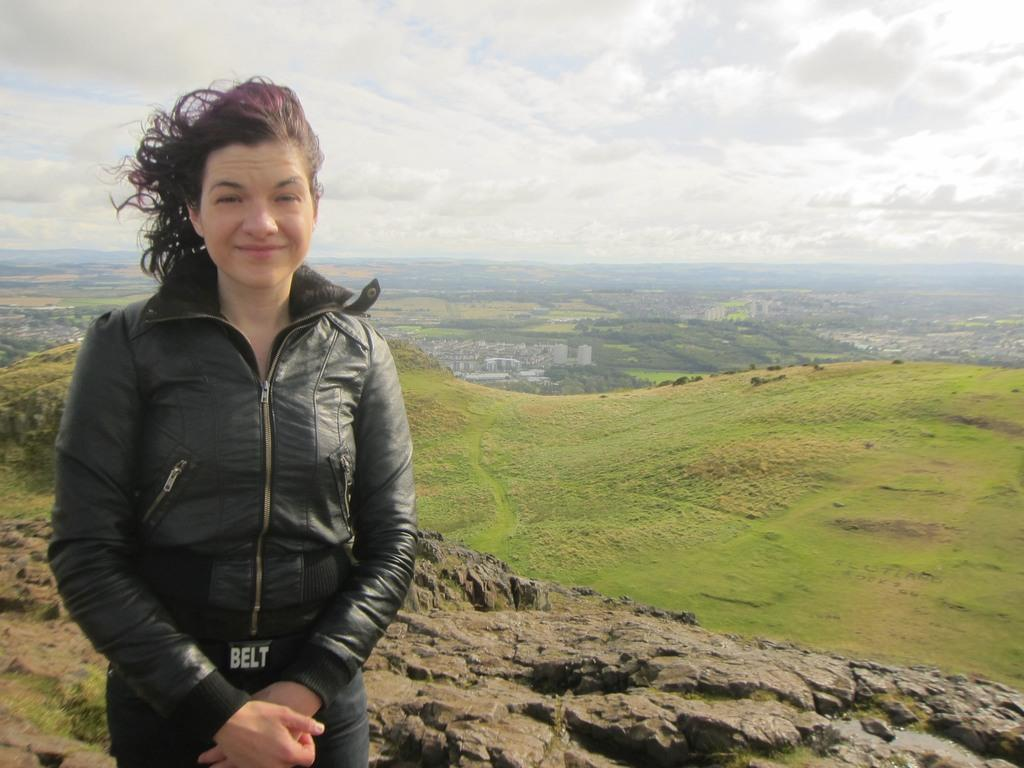Who is the main subject on the left side of the image? There is a beautiful woman standing on the left side of the image. What is the woman wearing in the image? The woman is wearing a black coat. What type of vegetation can be seen on the right side of the image? There is grass on the right side of the image. What is the condition of the sky in the image? The sky is cloudy and visible at the top of the image. What type of bells can be heard ringing in the image? There are no bells present in the image, and therefore no sound can be heard. What kind of cub is playing with the woman in the image? There is no cub present in the image; the woman is standing alone. 